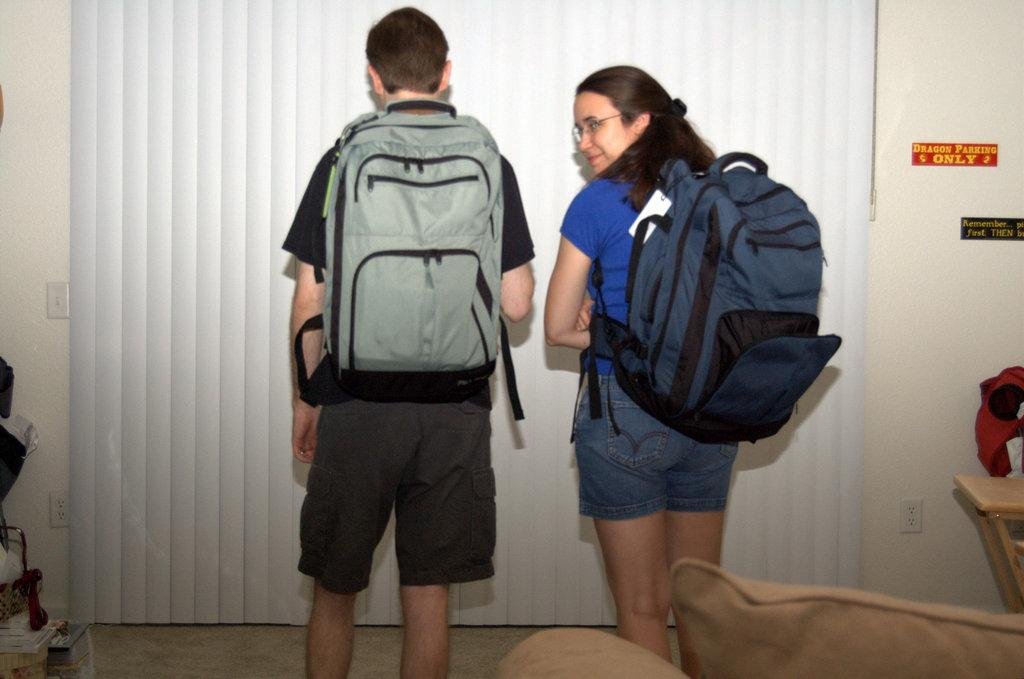<image>
Provide a brief description of the given image. Two people wearing backpacks and a small sticker on the wall that says: Dragon Parking Only 